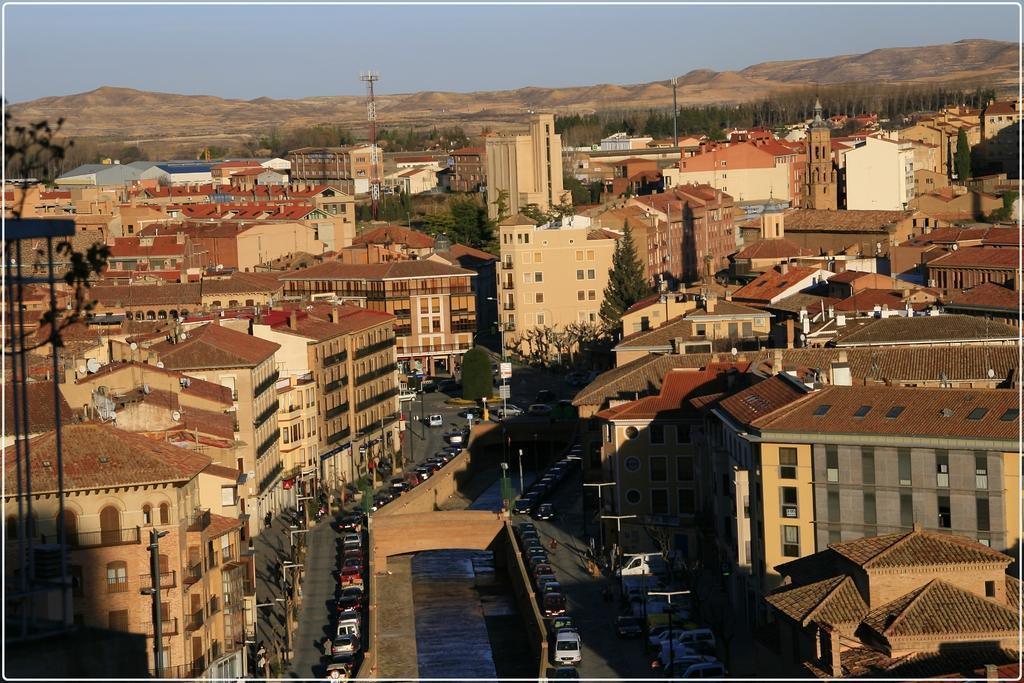In one or two sentences, can you explain what this image depicts? In this image we can see the mountains, so many buildings, antennas, poles, street lights, some boards attached to the poles, one canal, vehicles on the road, some vehicles are parked, some people on the road, some objects are on the surface, some trees, bushes, plants and grass on the surface. At the top there is the sky. 